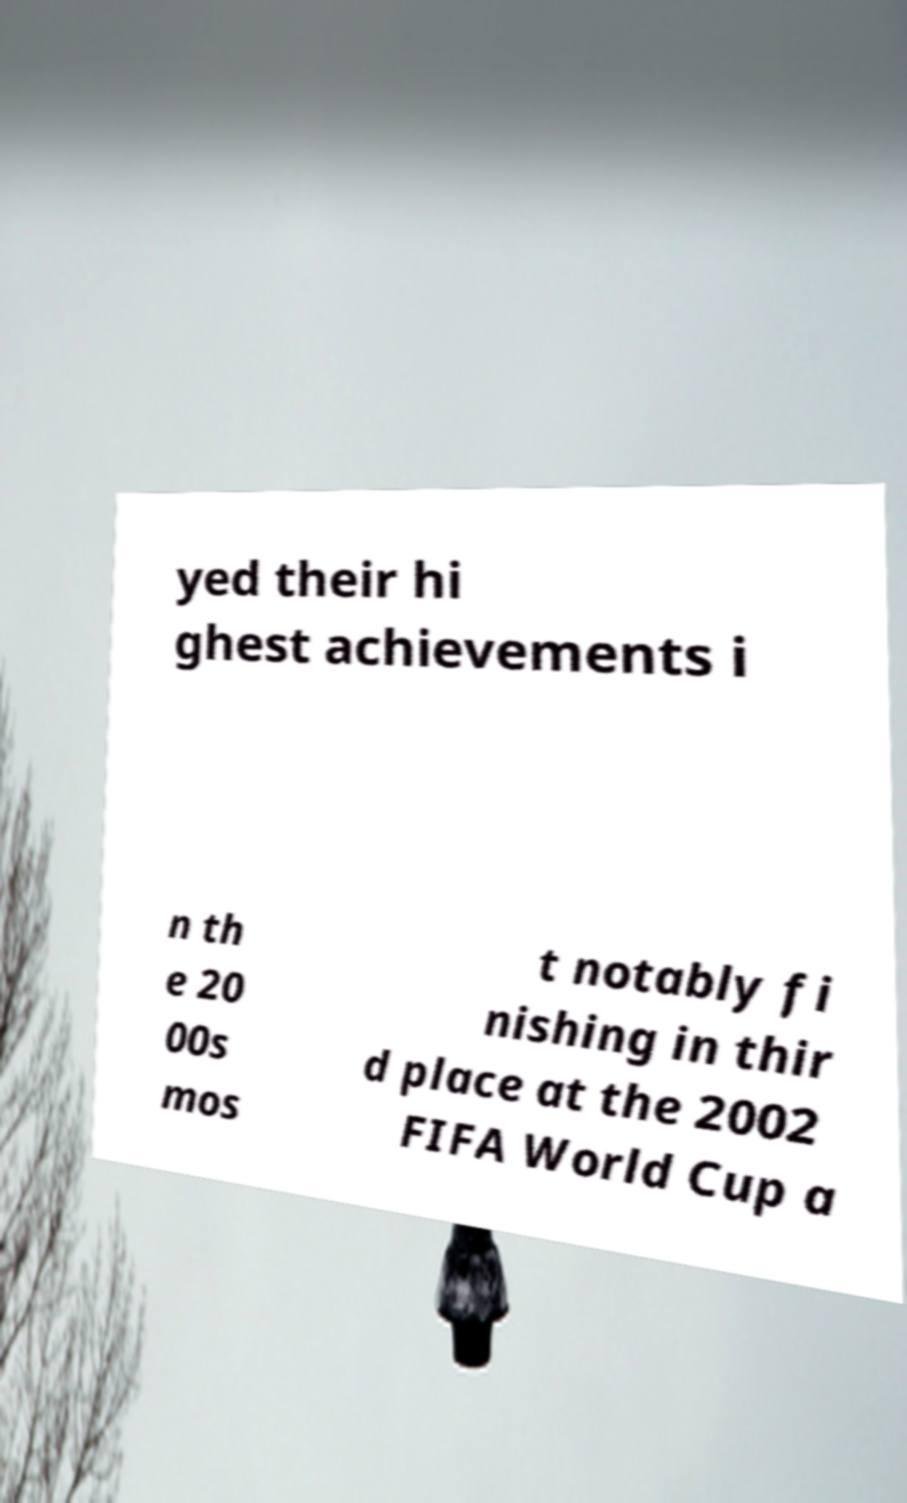For documentation purposes, I need the text within this image transcribed. Could you provide that? yed their hi ghest achievements i n th e 20 00s mos t notably fi nishing in thir d place at the 2002 FIFA World Cup a 